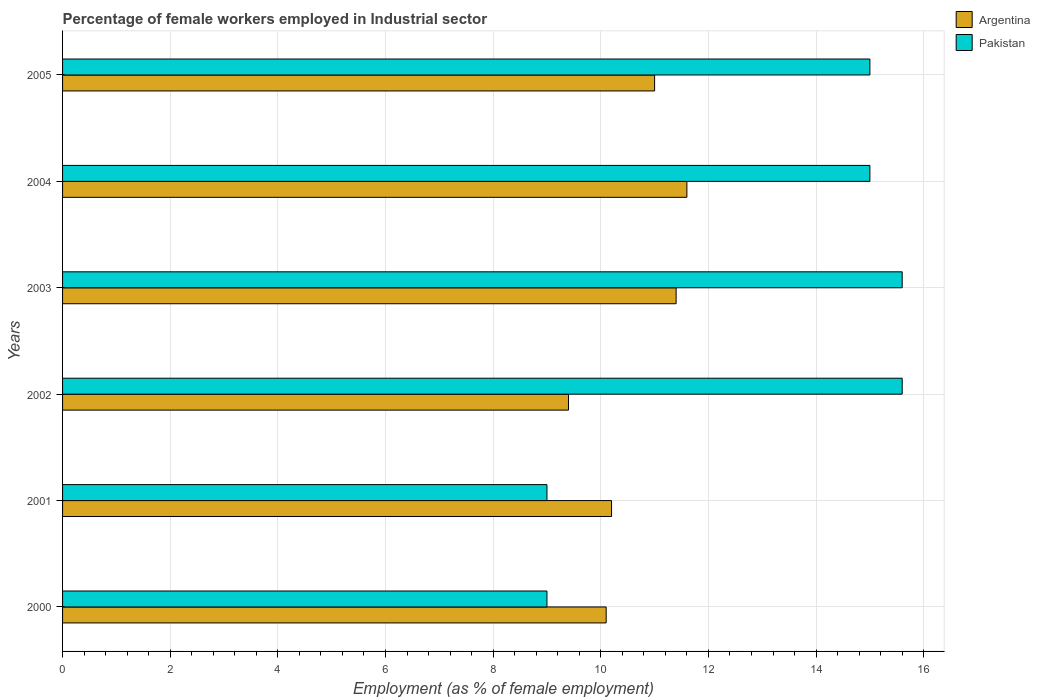Are the number of bars per tick equal to the number of legend labels?
Give a very brief answer. Yes. In how many cases, is the number of bars for a given year not equal to the number of legend labels?
Offer a terse response. 0. What is the percentage of females employed in Industrial sector in Pakistan in 2002?
Keep it short and to the point. 15.6. Across all years, what is the maximum percentage of females employed in Industrial sector in Argentina?
Offer a terse response. 11.6. Across all years, what is the minimum percentage of females employed in Industrial sector in Argentina?
Make the answer very short. 9.4. In which year was the percentage of females employed in Industrial sector in Argentina minimum?
Offer a terse response. 2002. What is the total percentage of females employed in Industrial sector in Pakistan in the graph?
Ensure brevity in your answer.  79.2. What is the difference between the percentage of females employed in Industrial sector in Pakistan in 2002 and that in 2005?
Your response must be concise. 0.6. What is the difference between the percentage of females employed in Industrial sector in Argentina in 2004 and the percentage of females employed in Industrial sector in Pakistan in 2003?
Your answer should be compact. -4. What is the average percentage of females employed in Industrial sector in Argentina per year?
Keep it short and to the point. 10.62. In the year 2002, what is the difference between the percentage of females employed in Industrial sector in Pakistan and percentage of females employed in Industrial sector in Argentina?
Give a very brief answer. 6.2. In how many years, is the percentage of females employed in Industrial sector in Argentina greater than 6.8 %?
Offer a terse response. 6. What is the ratio of the percentage of females employed in Industrial sector in Pakistan in 2000 to that in 2003?
Provide a succinct answer. 0.58. What is the difference between the highest and the lowest percentage of females employed in Industrial sector in Argentina?
Keep it short and to the point. 2.2. What does the 1st bar from the bottom in 2003 represents?
Your response must be concise. Argentina. How many bars are there?
Give a very brief answer. 12. Are all the bars in the graph horizontal?
Your response must be concise. Yes. How many years are there in the graph?
Your response must be concise. 6. What is the difference between two consecutive major ticks on the X-axis?
Your answer should be very brief. 2. Where does the legend appear in the graph?
Provide a succinct answer. Top right. What is the title of the graph?
Your answer should be very brief. Percentage of female workers employed in Industrial sector. Does "OECD members" appear as one of the legend labels in the graph?
Make the answer very short. No. What is the label or title of the X-axis?
Offer a terse response. Employment (as % of female employment). What is the Employment (as % of female employment) in Argentina in 2000?
Offer a very short reply. 10.1. What is the Employment (as % of female employment) of Pakistan in 2000?
Provide a short and direct response. 9. What is the Employment (as % of female employment) in Argentina in 2001?
Keep it short and to the point. 10.2. What is the Employment (as % of female employment) in Pakistan in 2001?
Provide a succinct answer. 9. What is the Employment (as % of female employment) in Argentina in 2002?
Make the answer very short. 9.4. What is the Employment (as % of female employment) of Pakistan in 2002?
Make the answer very short. 15.6. What is the Employment (as % of female employment) in Argentina in 2003?
Give a very brief answer. 11.4. What is the Employment (as % of female employment) in Pakistan in 2003?
Provide a short and direct response. 15.6. What is the Employment (as % of female employment) in Argentina in 2004?
Offer a terse response. 11.6. What is the Employment (as % of female employment) of Pakistan in 2005?
Give a very brief answer. 15. Across all years, what is the maximum Employment (as % of female employment) of Argentina?
Ensure brevity in your answer.  11.6. Across all years, what is the maximum Employment (as % of female employment) of Pakistan?
Your answer should be compact. 15.6. Across all years, what is the minimum Employment (as % of female employment) of Argentina?
Give a very brief answer. 9.4. What is the total Employment (as % of female employment) of Argentina in the graph?
Ensure brevity in your answer.  63.7. What is the total Employment (as % of female employment) in Pakistan in the graph?
Offer a terse response. 79.2. What is the difference between the Employment (as % of female employment) of Argentina in 2000 and that in 2002?
Provide a succinct answer. 0.7. What is the difference between the Employment (as % of female employment) in Pakistan in 2000 and that in 2003?
Your response must be concise. -6.6. What is the difference between the Employment (as % of female employment) in Pakistan in 2000 and that in 2004?
Your response must be concise. -6. What is the difference between the Employment (as % of female employment) in Argentina in 2000 and that in 2005?
Keep it short and to the point. -0.9. What is the difference between the Employment (as % of female employment) in Pakistan in 2000 and that in 2005?
Your response must be concise. -6. What is the difference between the Employment (as % of female employment) of Argentina in 2001 and that in 2003?
Your answer should be very brief. -1.2. What is the difference between the Employment (as % of female employment) of Argentina in 2001 and that in 2004?
Keep it short and to the point. -1.4. What is the difference between the Employment (as % of female employment) of Pakistan in 2001 and that in 2005?
Offer a very short reply. -6. What is the difference between the Employment (as % of female employment) in Argentina in 2002 and that in 2005?
Ensure brevity in your answer.  -1.6. What is the difference between the Employment (as % of female employment) of Pakistan in 2002 and that in 2005?
Keep it short and to the point. 0.6. What is the difference between the Employment (as % of female employment) of Argentina in 2003 and that in 2005?
Offer a terse response. 0.4. What is the difference between the Employment (as % of female employment) in Argentina in 2000 and the Employment (as % of female employment) in Pakistan in 2002?
Your answer should be compact. -5.5. What is the difference between the Employment (as % of female employment) in Argentina in 2000 and the Employment (as % of female employment) in Pakistan in 2003?
Give a very brief answer. -5.5. What is the difference between the Employment (as % of female employment) in Argentina in 2001 and the Employment (as % of female employment) in Pakistan in 2003?
Your answer should be very brief. -5.4. What is the difference between the Employment (as % of female employment) of Argentina in 2001 and the Employment (as % of female employment) of Pakistan in 2004?
Offer a terse response. -4.8. What is the difference between the Employment (as % of female employment) in Argentina in 2002 and the Employment (as % of female employment) in Pakistan in 2004?
Offer a terse response. -5.6. What is the difference between the Employment (as % of female employment) in Argentina in 2003 and the Employment (as % of female employment) in Pakistan in 2004?
Keep it short and to the point. -3.6. What is the difference between the Employment (as % of female employment) in Argentina in 2003 and the Employment (as % of female employment) in Pakistan in 2005?
Give a very brief answer. -3.6. What is the difference between the Employment (as % of female employment) in Argentina in 2004 and the Employment (as % of female employment) in Pakistan in 2005?
Ensure brevity in your answer.  -3.4. What is the average Employment (as % of female employment) of Argentina per year?
Provide a succinct answer. 10.62. What is the average Employment (as % of female employment) in Pakistan per year?
Make the answer very short. 13.2. In the year 2002, what is the difference between the Employment (as % of female employment) of Argentina and Employment (as % of female employment) of Pakistan?
Your response must be concise. -6.2. In the year 2005, what is the difference between the Employment (as % of female employment) in Argentina and Employment (as % of female employment) in Pakistan?
Ensure brevity in your answer.  -4. What is the ratio of the Employment (as % of female employment) of Argentina in 2000 to that in 2001?
Your answer should be compact. 0.99. What is the ratio of the Employment (as % of female employment) of Pakistan in 2000 to that in 2001?
Offer a very short reply. 1. What is the ratio of the Employment (as % of female employment) in Argentina in 2000 to that in 2002?
Offer a terse response. 1.07. What is the ratio of the Employment (as % of female employment) in Pakistan in 2000 to that in 2002?
Offer a very short reply. 0.58. What is the ratio of the Employment (as % of female employment) in Argentina in 2000 to that in 2003?
Your response must be concise. 0.89. What is the ratio of the Employment (as % of female employment) of Pakistan in 2000 to that in 2003?
Offer a terse response. 0.58. What is the ratio of the Employment (as % of female employment) in Argentina in 2000 to that in 2004?
Your answer should be compact. 0.87. What is the ratio of the Employment (as % of female employment) of Pakistan in 2000 to that in 2004?
Your response must be concise. 0.6. What is the ratio of the Employment (as % of female employment) of Argentina in 2000 to that in 2005?
Offer a terse response. 0.92. What is the ratio of the Employment (as % of female employment) in Argentina in 2001 to that in 2002?
Your answer should be very brief. 1.09. What is the ratio of the Employment (as % of female employment) of Pakistan in 2001 to that in 2002?
Provide a succinct answer. 0.58. What is the ratio of the Employment (as % of female employment) in Argentina in 2001 to that in 2003?
Offer a terse response. 0.89. What is the ratio of the Employment (as % of female employment) of Pakistan in 2001 to that in 2003?
Provide a short and direct response. 0.58. What is the ratio of the Employment (as % of female employment) in Argentina in 2001 to that in 2004?
Give a very brief answer. 0.88. What is the ratio of the Employment (as % of female employment) of Pakistan in 2001 to that in 2004?
Offer a very short reply. 0.6. What is the ratio of the Employment (as % of female employment) in Argentina in 2001 to that in 2005?
Provide a succinct answer. 0.93. What is the ratio of the Employment (as % of female employment) in Pakistan in 2001 to that in 2005?
Give a very brief answer. 0.6. What is the ratio of the Employment (as % of female employment) of Argentina in 2002 to that in 2003?
Your answer should be very brief. 0.82. What is the ratio of the Employment (as % of female employment) in Argentina in 2002 to that in 2004?
Your answer should be very brief. 0.81. What is the ratio of the Employment (as % of female employment) of Pakistan in 2002 to that in 2004?
Make the answer very short. 1.04. What is the ratio of the Employment (as % of female employment) of Argentina in 2002 to that in 2005?
Keep it short and to the point. 0.85. What is the ratio of the Employment (as % of female employment) of Pakistan in 2002 to that in 2005?
Ensure brevity in your answer.  1.04. What is the ratio of the Employment (as % of female employment) in Argentina in 2003 to that in 2004?
Your response must be concise. 0.98. What is the ratio of the Employment (as % of female employment) of Pakistan in 2003 to that in 2004?
Ensure brevity in your answer.  1.04. What is the ratio of the Employment (as % of female employment) of Argentina in 2003 to that in 2005?
Offer a very short reply. 1.04. What is the ratio of the Employment (as % of female employment) of Pakistan in 2003 to that in 2005?
Offer a very short reply. 1.04. What is the ratio of the Employment (as % of female employment) of Argentina in 2004 to that in 2005?
Ensure brevity in your answer.  1.05. What is the ratio of the Employment (as % of female employment) in Pakistan in 2004 to that in 2005?
Give a very brief answer. 1. What is the difference between the highest and the second highest Employment (as % of female employment) of Pakistan?
Give a very brief answer. 0. What is the difference between the highest and the lowest Employment (as % of female employment) of Argentina?
Ensure brevity in your answer.  2.2. What is the difference between the highest and the lowest Employment (as % of female employment) in Pakistan?
Offer a terse response. 6.6. 